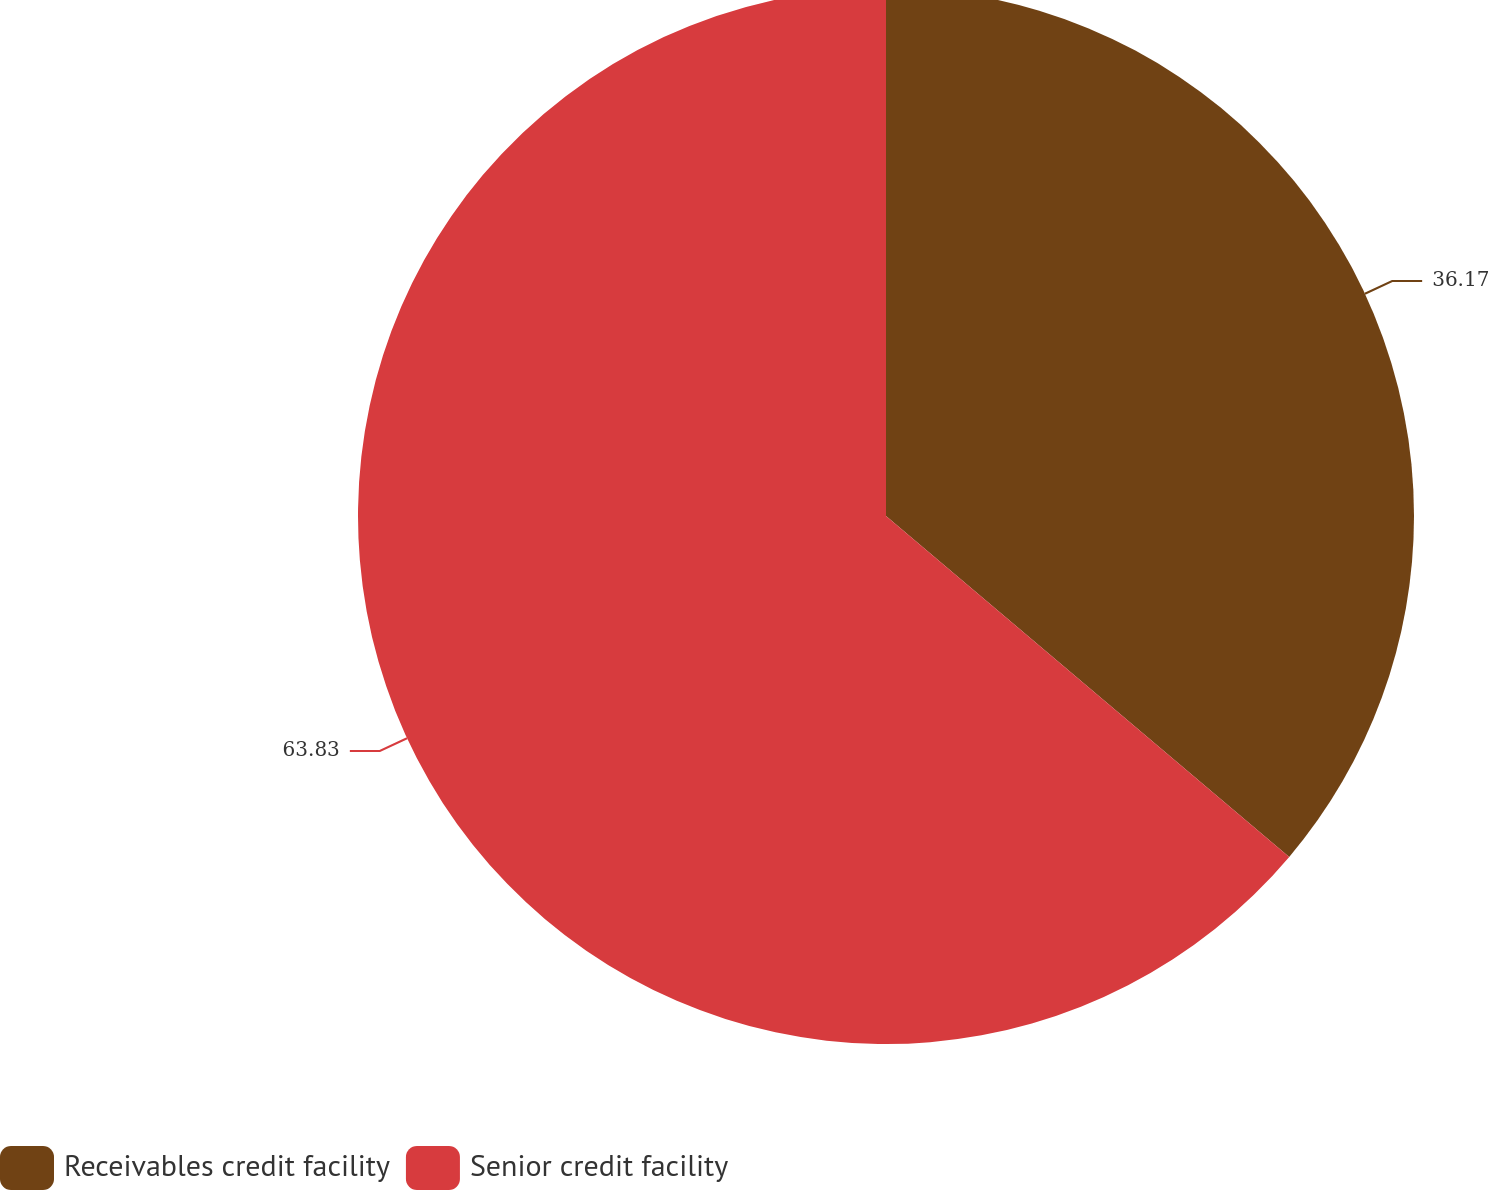Convert chart. <chart><loc_0><loc_0><loc_500><loc_500><pie_chart><fcel>Receivables credit facility<fcel>Senior credit facility<nl><fcel>36.17%<fcel>63.83%<nl></chart> 